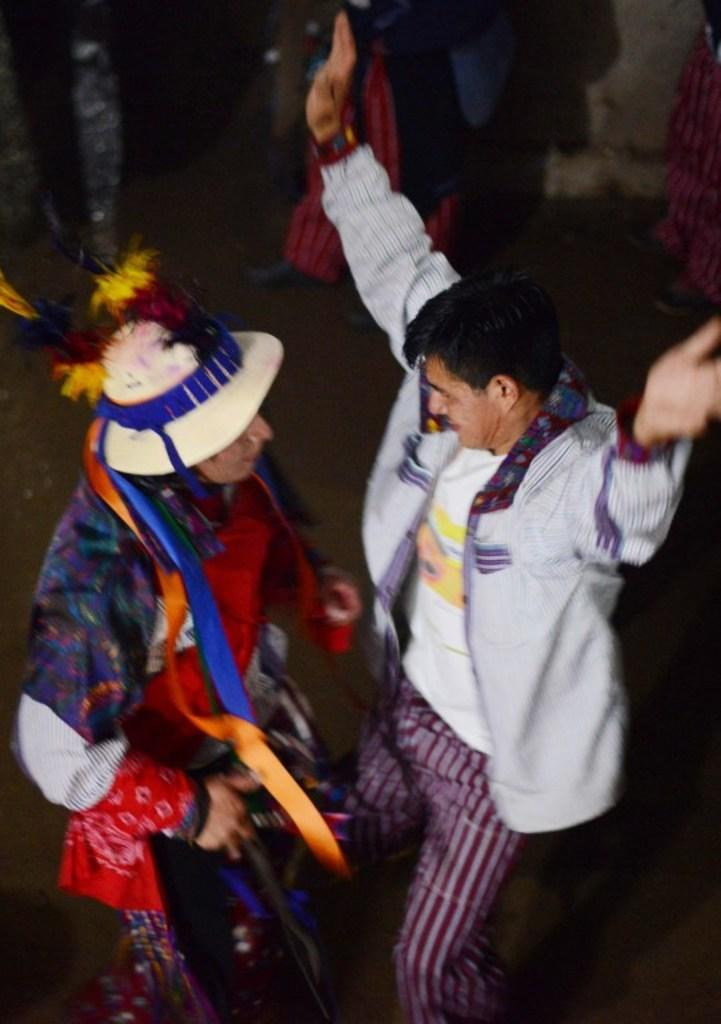What are the two people in the center of the image doing? The two people in the center of the image are dancing. How can you tell that the people are wearing different costumes? The people are wearing different costumes, which can be seen in the details of their clothing. What can be seen in the background of the image? There is a wall and people standing in the background of the image. What is the level of interest in the eyes of the people standing in the background? There is no information about the level of interest or the eyes of the people standing in the background, as the facts provided do not mention these details. 